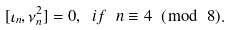<formula> <loc_0><loc_0><loc_500><loc_500>[ \iota _ { n } , \nu ^ { 2 } _ { n } ] = 0 , \ i f \ n \equiv 4 \ ( \bmod \ 8 ) .</formula> 